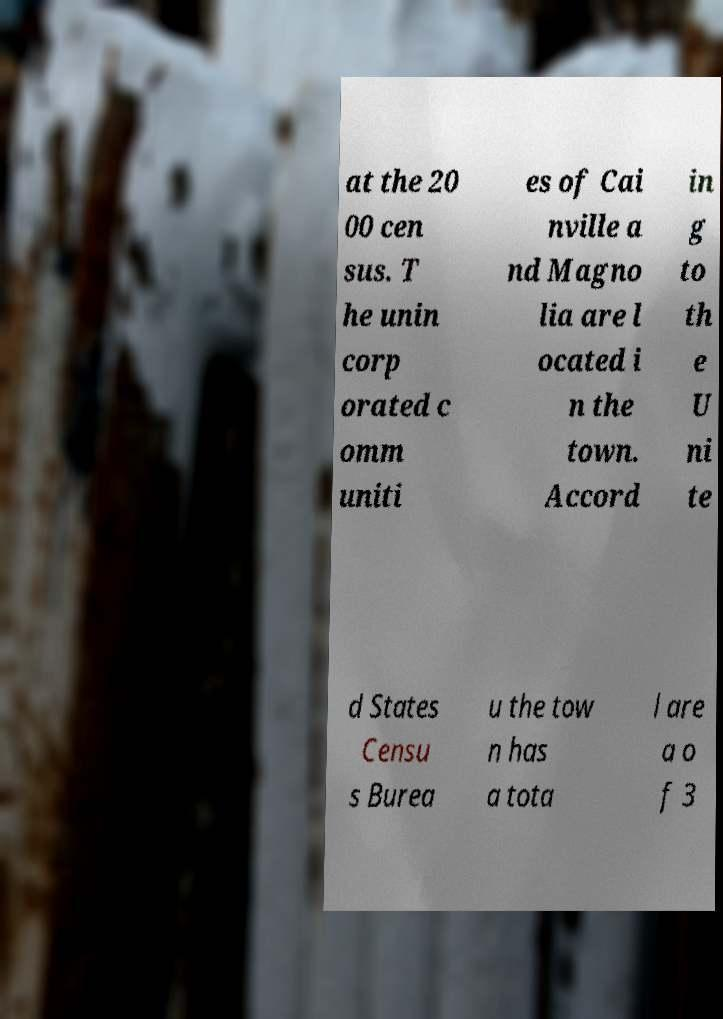Please read and relay the text visible in this image. What does it say? at the 20 00 cen sus. T he unin corp orated c omm uniti es of Cai nville a nd Magno lia are l ocated i n the town. Accord in g to th e U ni te d States Censu s Burea u the tow n has a tota l are a o f 3 